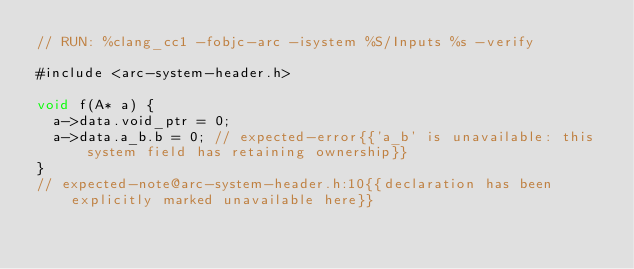Convert code to text. <code><loc_0><loc_0><loc_500><loc_500><_ObjectiveC_>// RUN: %clang_cc1 -fobjc-arc -isystem %S/Inputs %s -verify

#include <arc-system-header.h>

void f(A* a) {
  a->data.void_ptr = 0;
  a->data.a_b.b = 0; // expected-error{{'a_b' is unavailable: this system field has retaining ownership}}
}
// expected-note@arc-system-header.h:10{{declaration has been explicitly marked unavailable here}}
</code> 